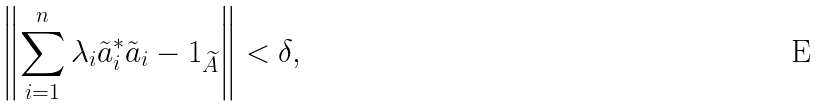<formula> <loc_0><loc_0><loc_500><loc_500>\left \| \sum ^ { n } _ { i = 1 } \lambda _ { i } \tilde { a } ^ { * } _ { i } \tilde { a } _ { i } - 1 _ { \widetilde { A } } \right \| < \delta ,</formula> 